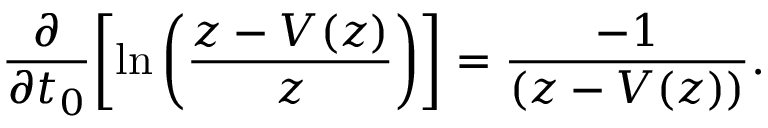<formula> <loc_0><loc_0><loc_500><loc_500>\frac { \partial } { \partial t _ { 0 } } \left [ \ln \left ( \frac { z - V ( z ) } { z } \right ) \right ] = \frac { - 1 } { \left ( z - V ( z ) \right ) } .</formula> 